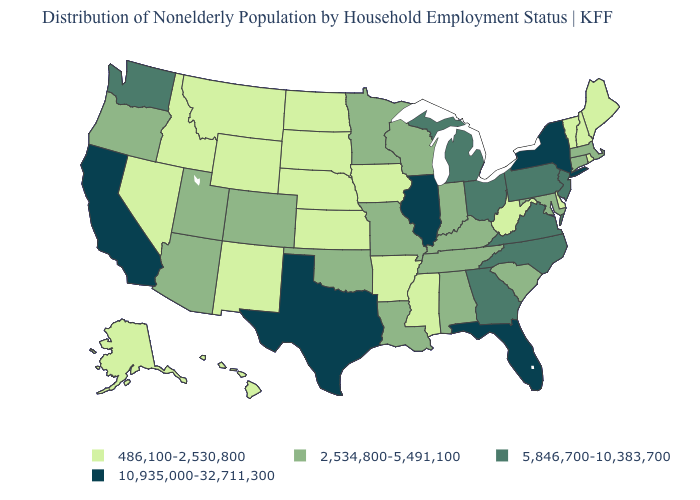What is the highest value in the USA?
Keep it brief. 10,935,000-32,711,300. What is the value of Idaho?
Give a very brief answer. 486,100-2,530,800. Name the states that have a value in the range 2,534,800-5,491,100?
Short answer required. Alabama, Arizona, Colorado, Connecticut, Indiana, Kentucky, Louisiana, Maryland, Massachusetts, Minnesota, Missouri, Oklahoma, Oregon, South Carolina, Tennessee, Utah, Wisconsin. Name the states that have a value in the range 10,935,000-32,711,300?
Be succinct. California, Florida, Illinois, New York, Texas. Name the states that have a value in the range 10,935,000-32,711,300?
Be succinct. California, Florida, Illinois, New York, Texas. Among the states that border Texas , does Oklahoma have the highest value?
Keep it brief. Yes. Does Arkansas have a higher value than Iowa?
Answer briefly. No. Does Oregon have a higher value than Washington?
Keep it brief. No. Name the states that have a value in the range 486,100-2,530,800?
Answer briefly. Alaska, Arkansas, Delaware, Hawaii, Idaho, Iowa, Kansas, Maine, Mississippi, Montana, Nebraska, Nevada, New Hampshire, New Mexico, North Dakota, Rhode Island, South Dakota, Vermont, West Virginia, Wyoming. Name the states that have a value in the range 486,100-2,530,800?
Give a very brief answer. Alaska, Arkansas, Delaware, Hawaii, Idaho, Iowa, Kansas, Maine, Mississippi, Montana, Nebraska, Nevada, New Hampshire, New Mexico, North Dakota, Rhode Island, South Dakota, Vermont, West Virginia, Wyoming. Name the states that have a value in the range 486,100-2,530,800?
Answer briefly. Alaska, Arkansas, Delaware, Hawaii, Idaho, Iowa, Kansas, Maine, Mississippi, Montana, Nebraska, Nevada, New Hampshire, New Mexico, North Dakota, Rhode Island, South Dakota, Vermont, West Virginia, Wyoming. What is the value of North Dakota?
Answer briefly. 486,100-2,530,800. Does the first symbol in the legend represent the smallest category?
Short answer required. Yes. Name the states that have a value in the range 10,935,000-32,711,300?
Answer briefly. California, Florida, Illinois, New York, Texas. 